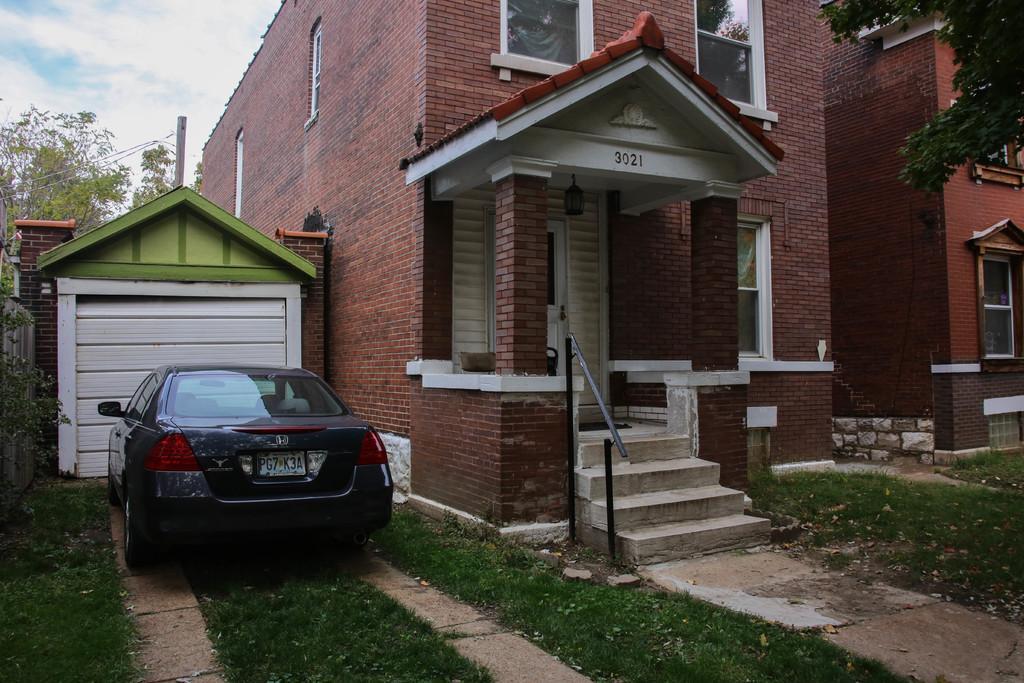Describe this image in one or two sentences. In this picture there is a house in the center of the image and there are stairs in front of it and there are other houses on the right and left side of the image and there is grassland at the bottom side of the image and there are trees in the background area of the image, there is a car on the left side of the image. 